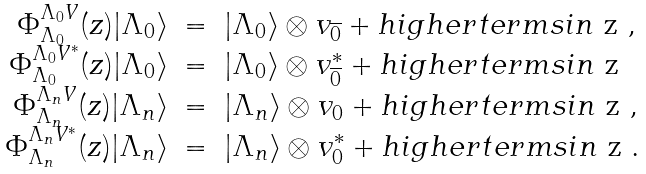<formula> <loc_0><loc_0><loc_500><loc_500>\begin{array} { r c l } \Phi ^ { \Lambda _ { 0 } V } _ { \Lambda _ { 0 } } ( z ) | \Lambda _ { 0 } \rangle & = & | \Lambda _ { 0 } \rangle \otimes v _ { \overline { 0 } } + h i g h e r t e r m s i n $ z $ , \\ \Phi ^ { \Lambda _ { 0 } V ^ { * } } _ { \Lambda _ { 0 } } ( z ) | \Lambda _ { 0 } \rangle & = & | \Lambda _ { 0 } \rangle \otimes v _ { \overline { 0 } } ^ { * } + h i g h e r t e r m s i n $ z $ \\ \Phi ^ { \Lambda _ { n } V } _ { \Lambda _ { n } } ( z ) | \Lambda _ { n } \rangle & = & | \Lambda _ { n } \rangle \otimes v _ { 0 } + h i g h e r t e r m s i n $ z $ , \\ \Phi ^ { \Lambda _ { n } V ^ { * } } _ { \Lambda _ { n } } ( z ) | \Lambda _ { n } \rangle & = & | \Lambda _ { n } \rangle \otimes v _ { 0 } ^ { * } + h i g h e r t e r m s i n $ z $ . \end{array}</formula> 